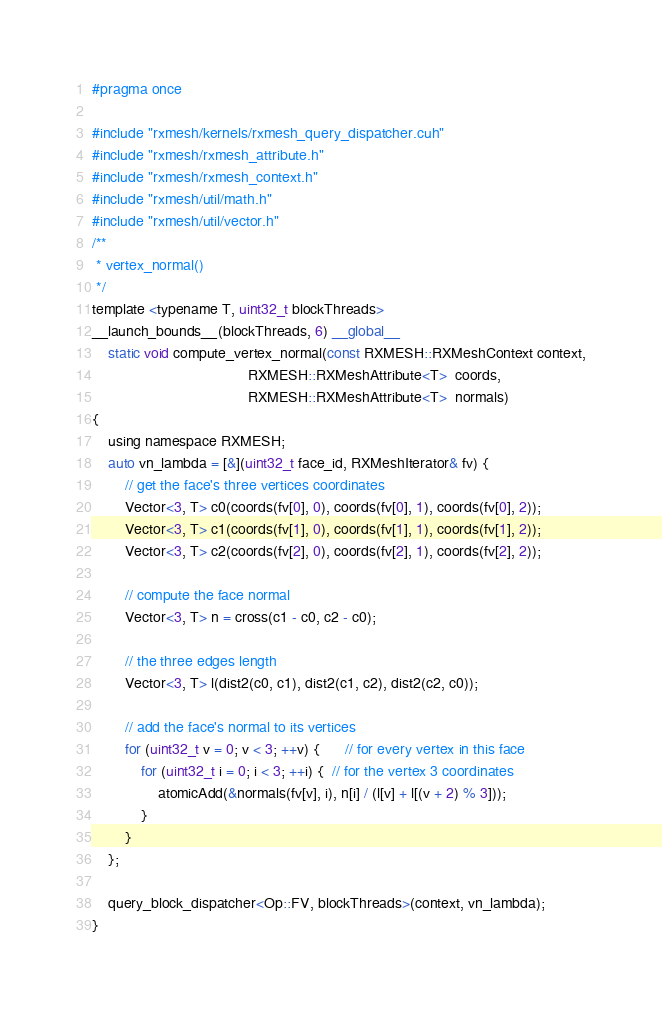Convert code to text. <code><loc_0><loc_0><loc_500><loc_500><_Cuda_>#pragma once

#include "rxmesh/kernels/rxmesh_query_dispatcher.cuh"
#include "rxmesh/rxmesh_attribute.h"
#include "rxmesh/rxmesh_context.h"
#include "rxmesh/util/math.h"
#include "rxmesh/util/vector.h"
/**
 * vertex_normal()
 */
template <typename T, uint32_t blockThreads>
__launch_bounds__(blockThreads, 6) __global__
    static void compute_vertex_normal(const RXMESH::RXMeshContext context,
                                      RXMESH::RXMeshAttribute<T>  coords,
                                      RXMESH::RXMeshAttribute<T>  normals)
{
    using namespace RXMESH;
    auto vn_lambda = [&](uint32_t face_id, RXMeshIterator& fv) {
        // get the face's three vertices coordinates
        Vector<3, T> c0(coords(fv[0], 0), coords(fv[0], 1), coords(fv[0], 2));
        Vector<3, T> c1(coords(fv[1], 0), coords(fv[1], 1), coords(fv[1], 2));
        Vector<3, T> c2(coords(fv[2], 0), coords(fv[2], 1), coords(fv[2], 2));

        // compute the face normal
        Vector<3, T> n = cross(c1 - c0, c2 - c0);

        // the three edges length
        Vector<3, T> l(dist2(c0, c1), dist2(c1, c2), dist2(c2, c0));

        // add the face's normal to its vertices
        for (uint32_t v = 0; v < 3; ++v) {      // for every vertex in this face
            for (uint32_t i = 0; i < 3; ++i) {  // for the vertex 3 coordinates
                atomicAdd(&normals(fv[v], i), n[i] / (l[v] + l[(v + 2) % 3]));
            }
        }
    };

    query_block_dispatcher<Op::FV, blockThreads>(context, vn_lambda);
}</code> 